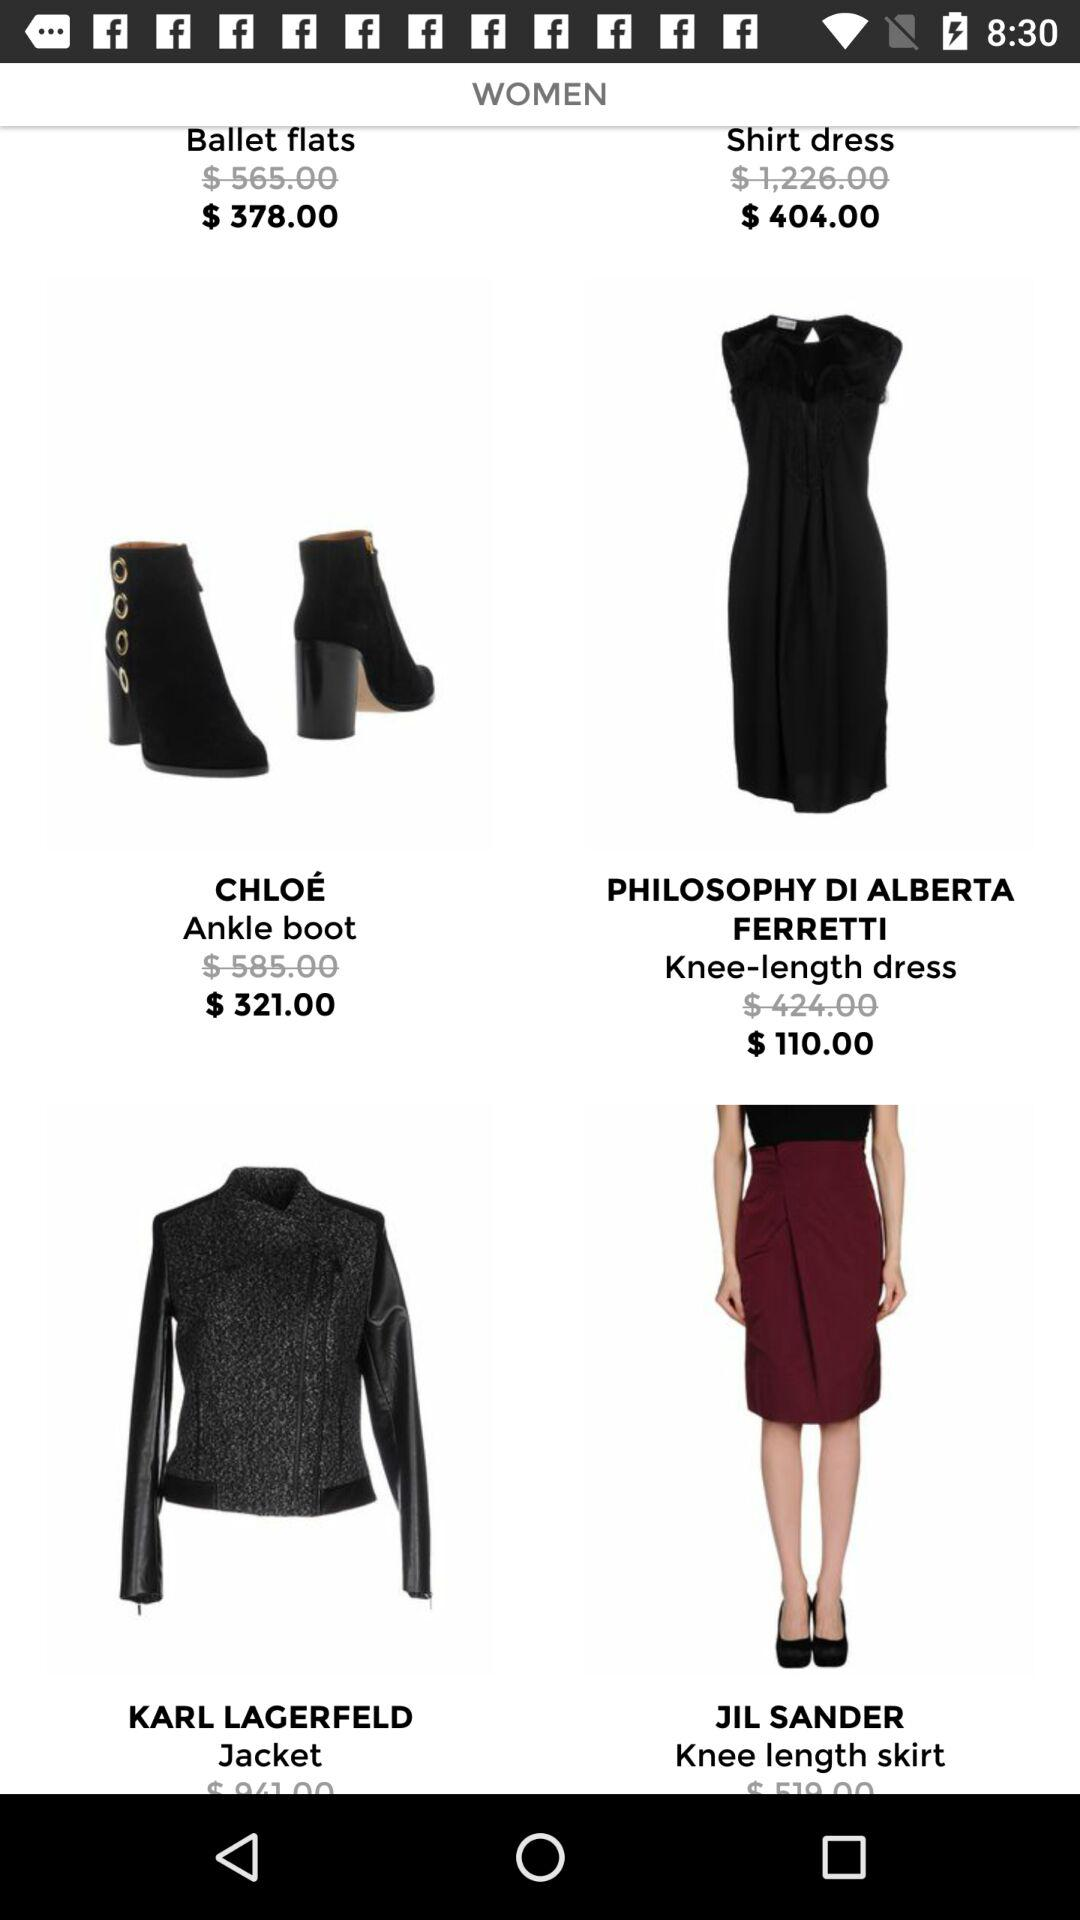What's the cost of "Ankle boot"? The cost is $321.00. 